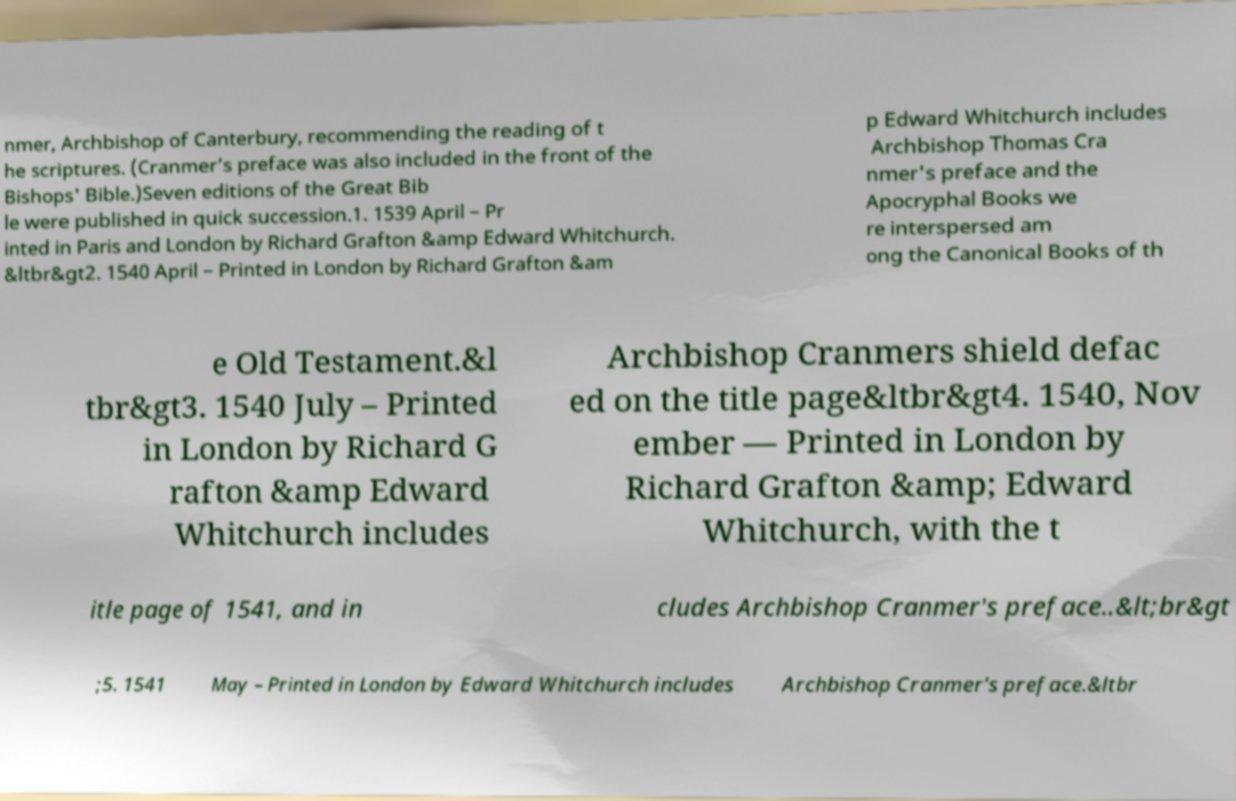Could you extract and type out the text from this image? nmer, Archbishop of Canterbury, recommending the reading of t he scriptures. (Cranmer’s preface was also included in the front of the Bishops' Bible.)Seven editions of the Great Bib le were published in quick succession.1. 1539 April – Pr inted in Paris and London by Richard Grafton &amp Edward Whitchurch. &ltbr&gt2. 1540 April – Printed in London by Richard Grafton &am p Edward Whitchurch includes Archbishop Thomas Cra nmer's preface and the Apocryphal Books we re interspersed am ong the Canonical Books of th e Old Testament.&l tbr&gt3. 1540 July – Printed in London by Richard G rafton &amp Edward Whitchurch includes Archbishop Cranmers shield defac ed on the title page&ltbr&gt4. 1540, Nov ember — Printed in London by Richard Grafton &amp; Edward Whitchurch, with the t itle page of 1541, and in cludes Archbishop Cranmer's preface..&lt;br&gt ;5. 1541 May – Printed in London by Edward Whitchurch includes Archbishop Cranmer's preface.&ltbr 